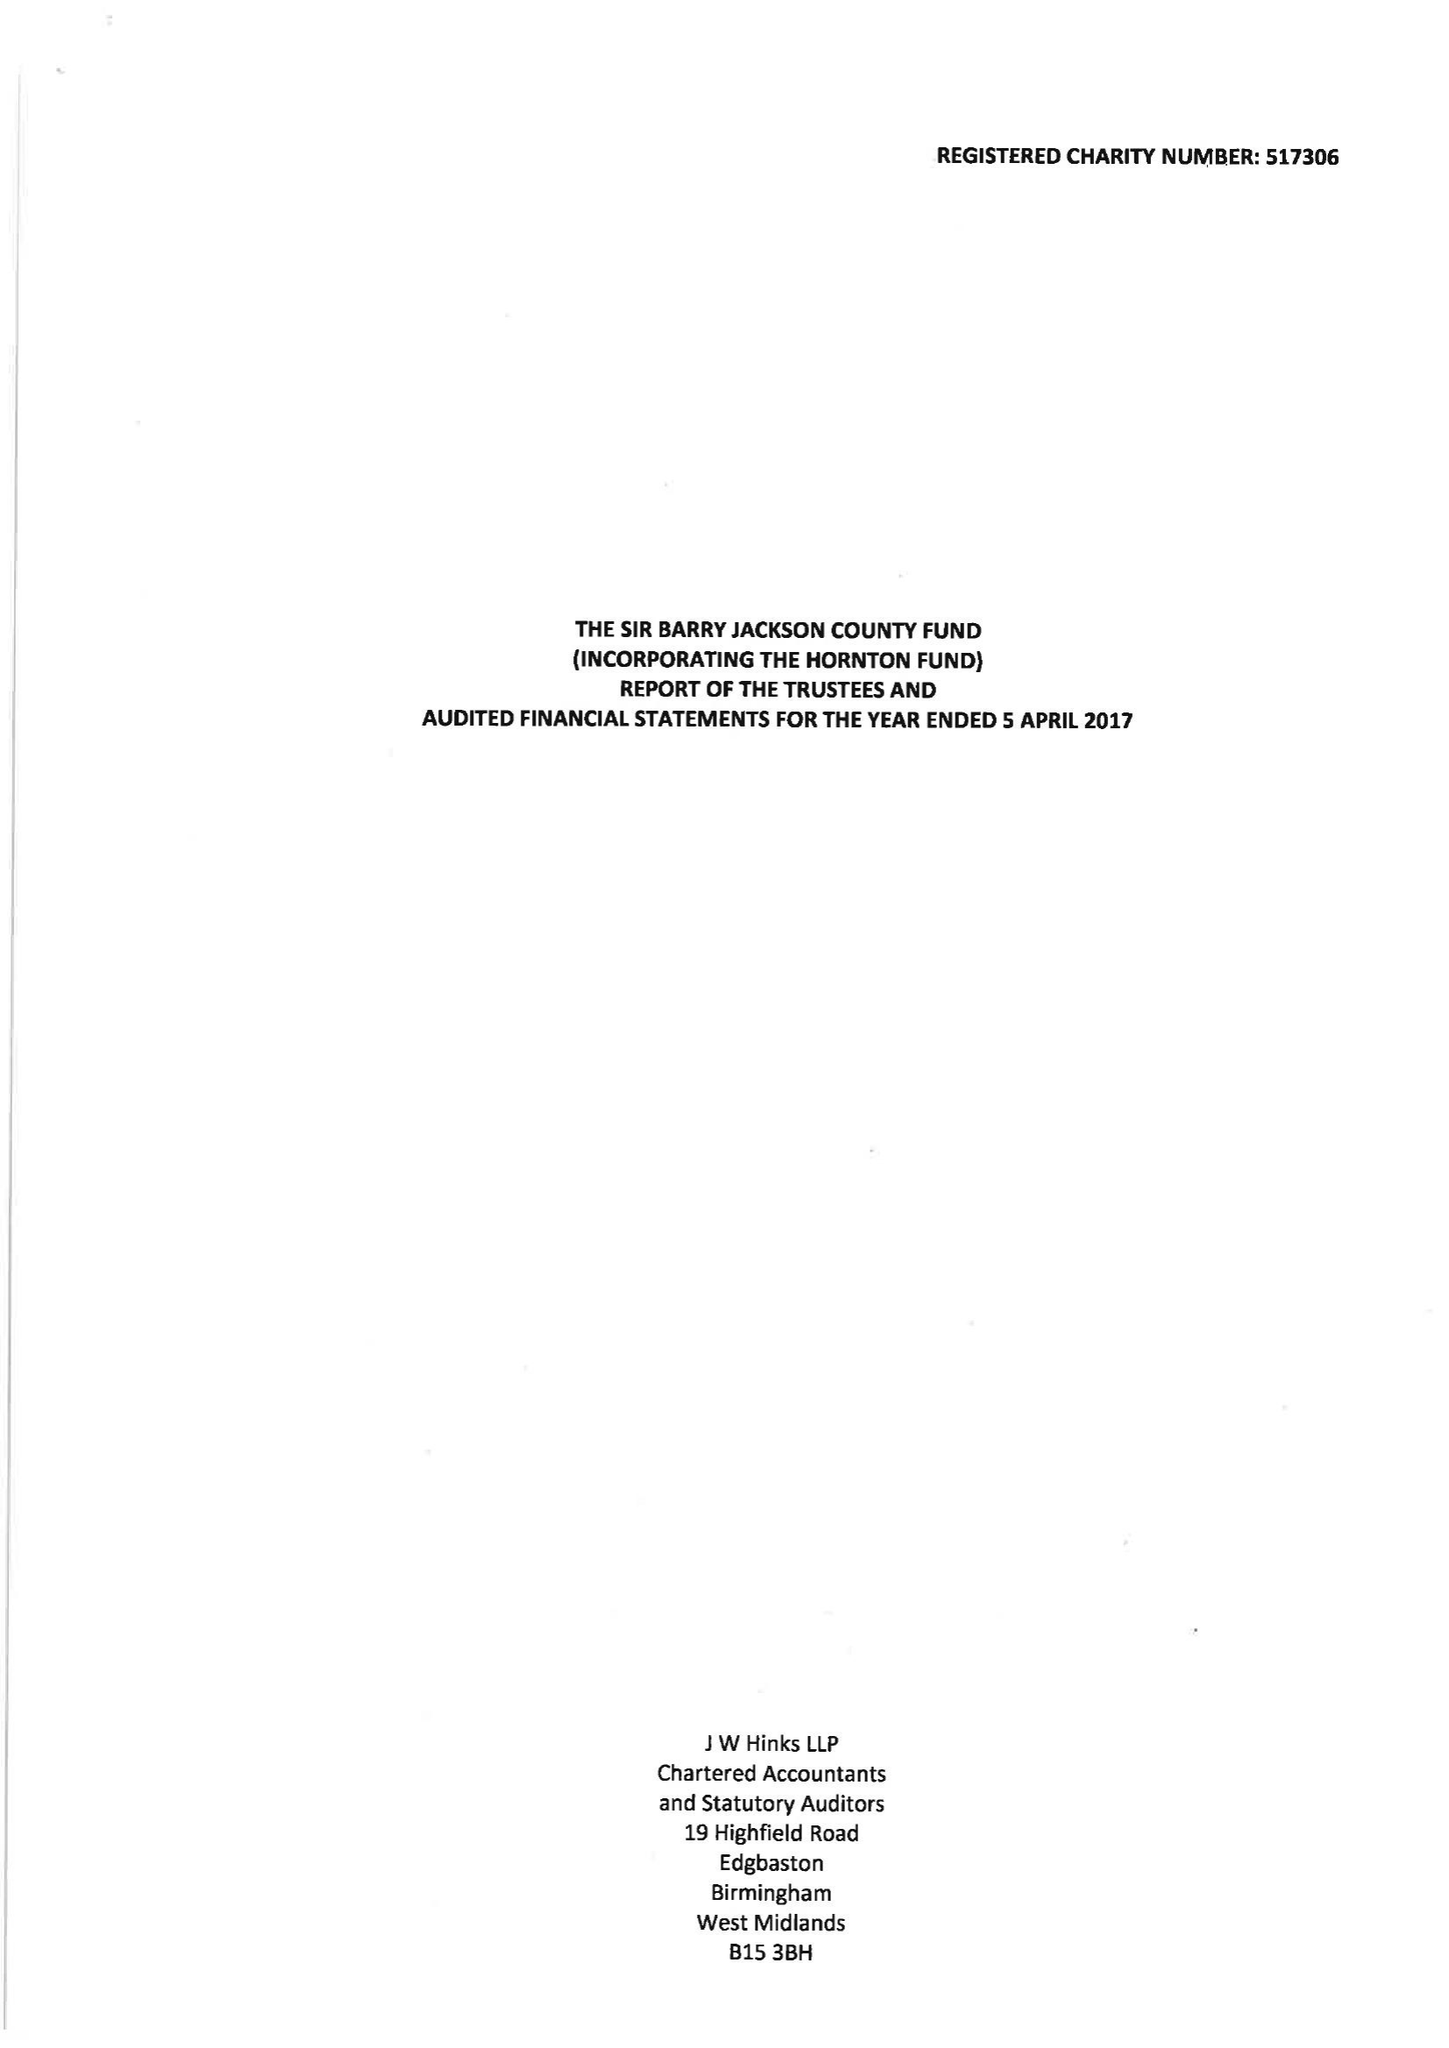What is the value for the report_date?
Answer the question using a single word or phrase. 2017-04-05 